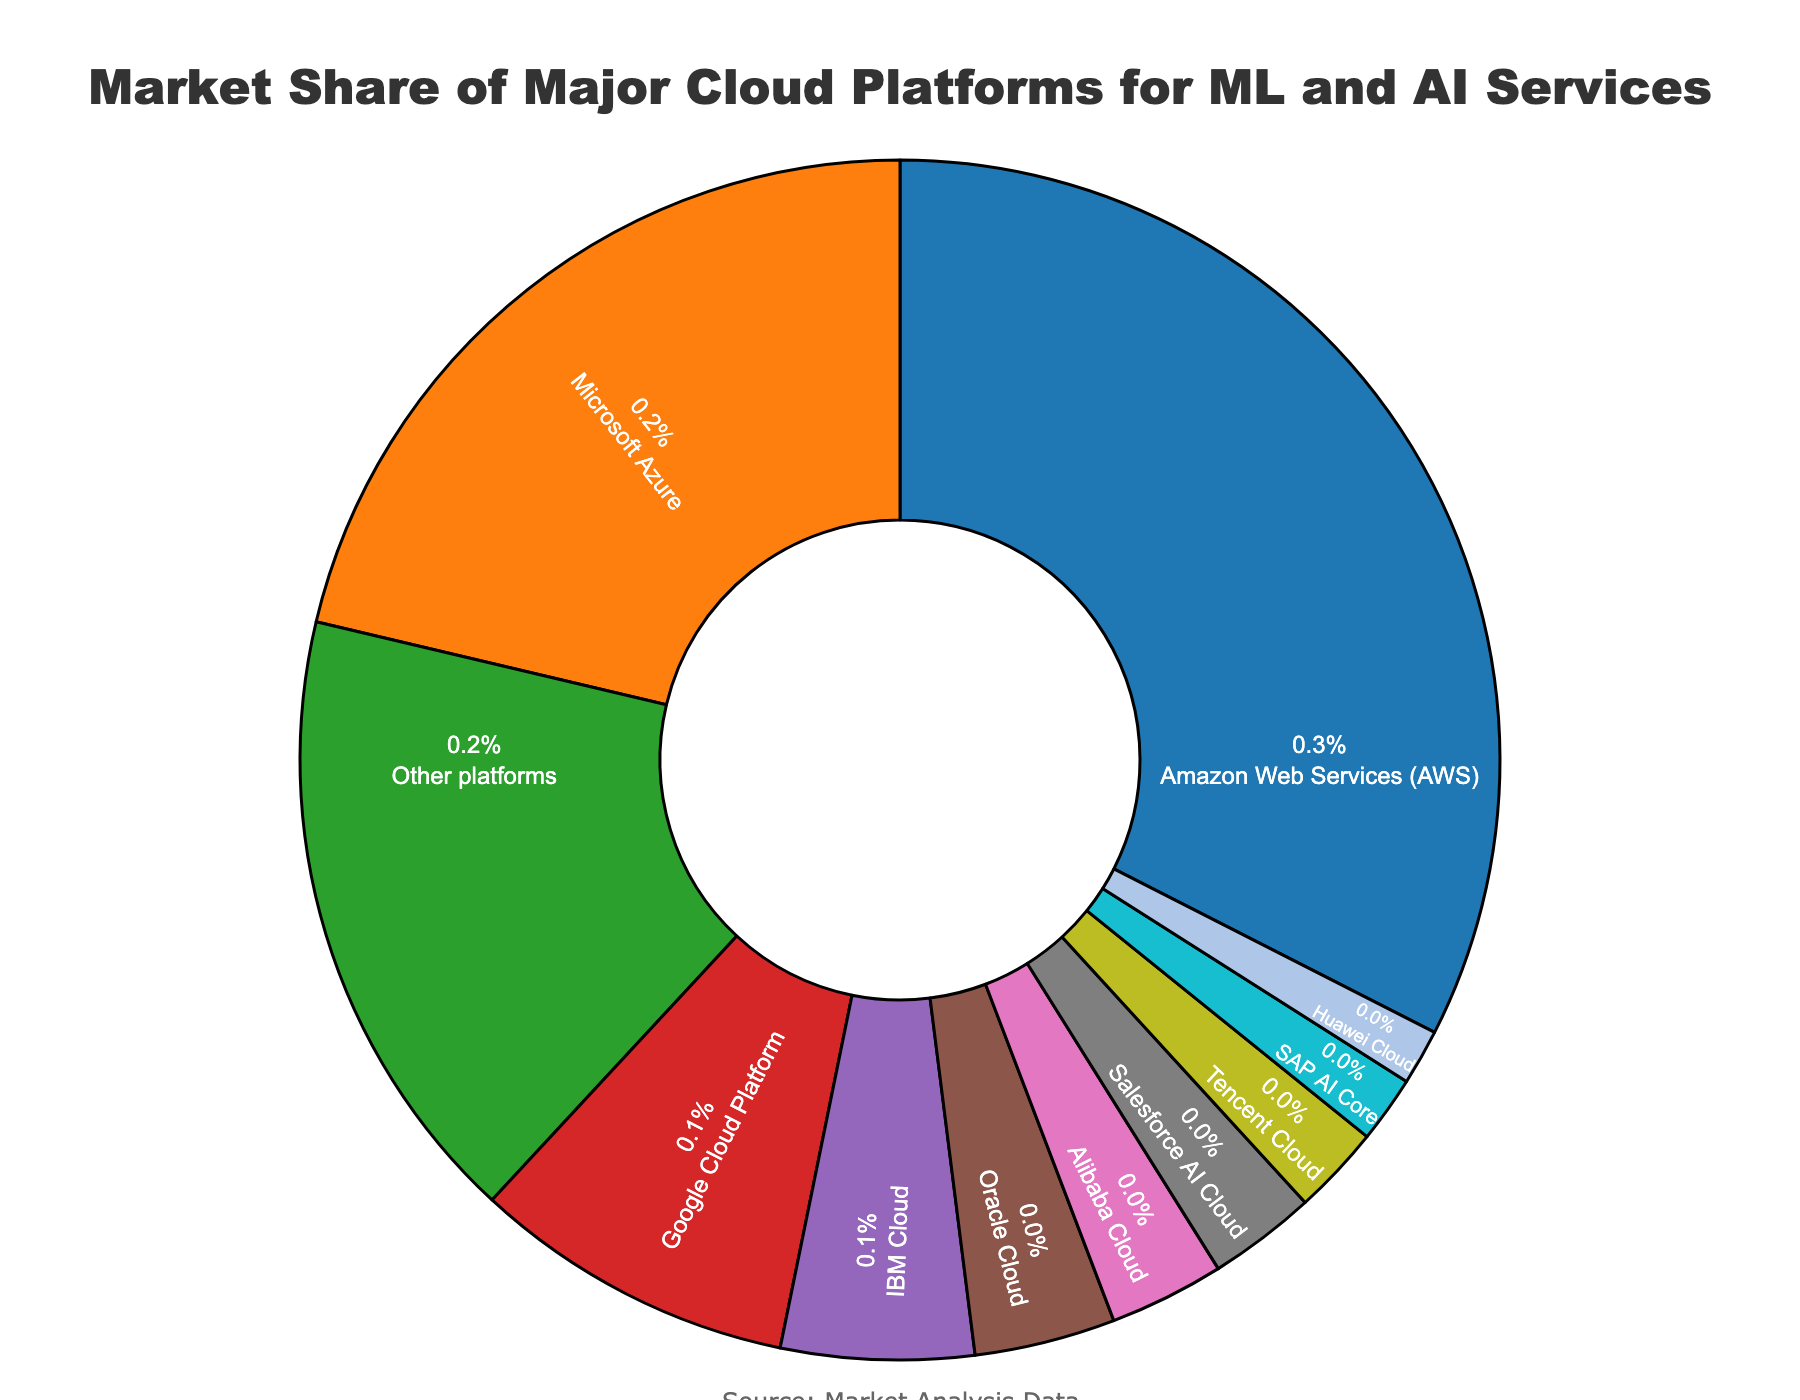What's the market share of the top three cloud platforms combined? First, identify the market share percentages of the top three cloud platforms: Amazon Web Services (AWS), Microsoft Azure, and Google Cloud Platform. AWS has 32.5%, Microsoft Azure has 21.3%, and Google Cloud Platform has 8.7%. Then sum these percentages: 32.5 + 21.3 + 8.7 = 62.5.
Answer: 62.5% Which cloud platform has the smallest market share and what is the percentage? Identify the cloud platform with the lowest market share by looking at the data: Huawei Cloud has the smallest market share with 1.5%.
Answer: Huawei Cloud, 1.5% How much more market share does Amazon Web Services (AWS) have compared to Tencent Cloud? Find the market shares of AWS and Tencent Cloud: AWS has 32.5%, and Tencent Cloud has 2.4%. Calculate the difference: 32.5 - 2.4 = 30.1.
Answer: 30.1% Which cloud platforms have a market share greater than 5%? Look at the list and identify cloud platforms with market shares greater than 5%: AWS (32.5%), Microsoft Azure (21.3%), and Google Cloud Platform (8.7%) have shares greater than 5%.
Answer: AWS, Microsoft Azure, Google Cloud Platform What is the total market share of IBM Cloud and Oracle Cloud combined? IBM Cloud has a market share of 5.2% and Oracle Cloud has 3.8%. Add these together: 5.2 + 3.8 = 9.
Answer: 9% What color represents Salesforce AI Cloud? Salesforce AI Cloud is represented by the color pink (#e377c2 according to the given custom color scale).
Answer: Pink What is the difference between the market share of Microsoft Azure and Google Cloud Platform? Microsoft Azure has a market share of 21.3% and Google Cloud Platform has 8.7%. Find the difference: 21.3 - 8.7 = 12.6.
Answer: 12.6% List all platforms with market shares below 3%. Identify platforms with market shares below 3%: Alibaba Cloud (3.1%), Salesforce AI Cloud (2.9%), Tencent Cloud (2.4%), SAP AI Core (1.8%), Huawei Cloud (1.5%).
Answer: Alibaba Cloud, Salesforce AI Cloud, Tencent Cloud, SAP AI Core, Huawei Cloud 